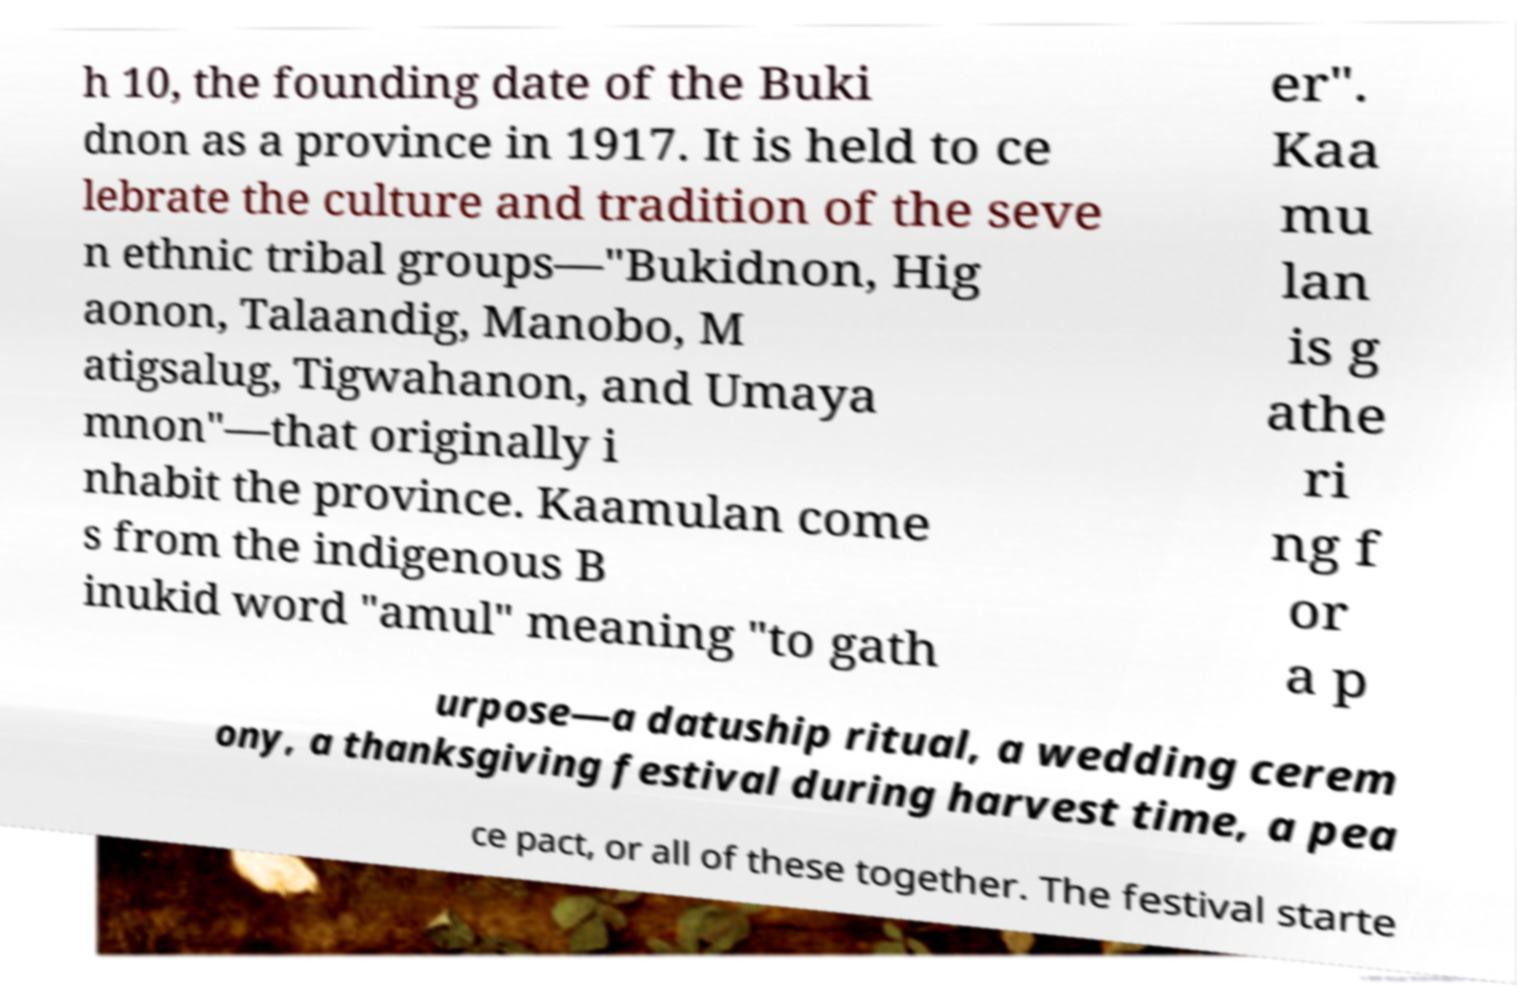Please identify and transcribe the text found in this image. h 10, the founding date of the Buki dnon as a province in 1917. It is held to ce lebrate the culture and tradition of the seve n ethnic tribal groups—"Bukidnon, Hig aonon, Talaandig, Manobo, M atigsalug, Tigwahanon, and Umaya mnon"—that originally i nhabit the province. Kaamulan come s from the indigenous B inukid word "amul" meaning "to gath er". Kaa mu lan is g athe ri ng f or a p urpose—a datuship ritual, a wedding cerem ony, a thanksgiving festival during harvest time, a pea ce pact, or all of these together. The festival starte 